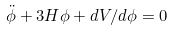Convert formula to latex. <formula><loc_0><loc_0><loc_500><loc_500>\ddot { \phi } + 3 H { \phi } + d V / d \phi = 0</formula> 